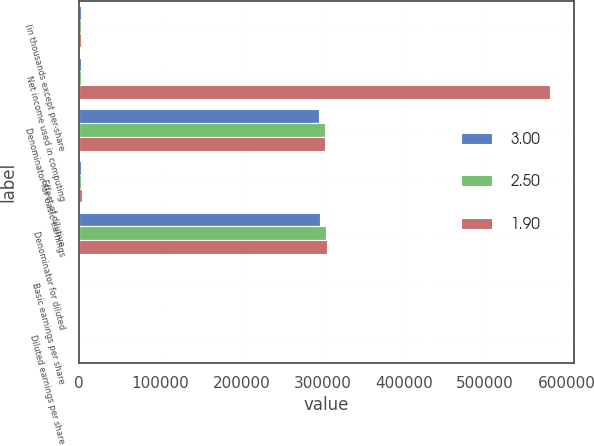Convert chart. <chart><loc_0><loc_0><loc_500><loc_500><stacked_bar_chart><ecel><fcel>(in thousands except per-share<fcel>Net income used in computing<fcel>Denominator for basic earnings<fcel>Effect of dilutive<fcel>Denominator for diluted<fcel>Basic earnings per share<fcel>Diluted earnings per share<nl><fcel>3<fcel>2004<fcel>2004<fcel>295008<fcel>1844<fcel>296852<fcel>3.02<fcel>3<nl><fcel>2.5<fcel>2003<fcel>2004<fcel>302271<fcel>2199<fcel>304470<fcel>2.52<fcel>2.5<nl><fcel>1.9<fcel>2002<fcel>580217<fcel>302297<fcel>2861<fcel>305158<fcel>1.92<fcel>1.9<nl></chart> 